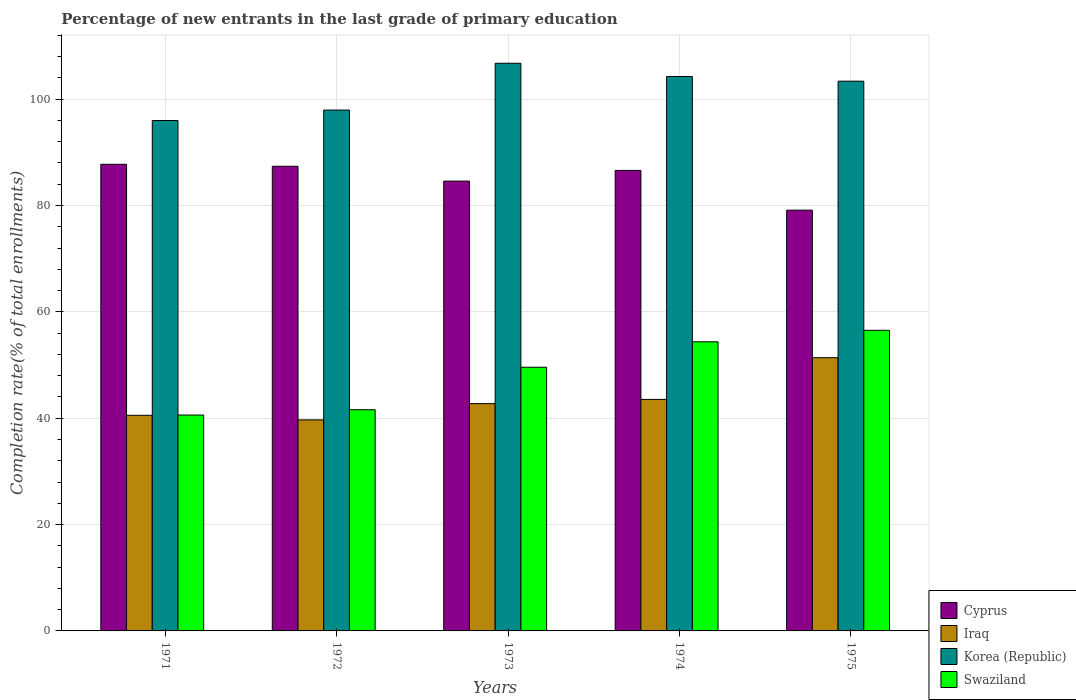How many groups of bars are there?
Offer a very short reply. 5. Are the number of bars per tick equal to the number of legend labels?
Provide a succinct answer. Yes. How many bars are there on the 1st tick from the left?
Provide a short and direct response. 4. What is the label of the 1st group of bars from the left?
Make the answer very short. 1971. In how many cases, is the number of bars for a given year not equal to the number of legend labels?
Make the answer very short. 0. What is the percentage of new entrants in Iraq in 1974?
Make the answer very short. 43.54. Across all years, what is the maximum percentage of new entrants in Iraq?
Your answer should be compact. 51.38. Across all years, what is the minimum percentage of new entrants in Cyprus?
Your response must be concise. 79.12. In which year was the percentage of new entrants in Iraq maximum?
Offer a terse response. 1975. In which year was the percentage of new entrants in Cyprus minimum?
Your answer should be very brief. 1975. What is the total percentage of new entrants in Swaziland in the graph?
Offer a terse response. 242.67. What is the difference between the percentage of new entrants in Cyprus in 1972 and that in 1975?
Your response must be concise. 8.26. What is the difference between the percentage of new entrants in Swaziland in 1973 and the percentage of new entrants in Korea (Republic) in 1974?
Provide a succinct answer. -54.67. What is the average percentage of new entrants in Iraq per year?
Keep it short and to the point. 43.58. In the year 1973, what is the difference between the percentage of new entrants in Korea (Republic) and percentage of new entrants in Cyprus?
Provide a short and direct response. 22.16. What is the ratio of the percentage of new entrants in Swaziland in 1973 to that in 1975?
Your response must be concise. 0.88. Is the percentage of new entrants in Iraq in 1972 less than that in 1975?
Your answer should be very brief. Yes. What is the difference between the highest and the second highest percentage of new entrants in Korea (Republic)?
Offer a very short reply. 2.5. What is the difference between the highest and the lowest percentage of new entrants in Swaziland?
Give a very brief answer. 15.93. In how many years, is the percentage of new entrants in Iraq greater than the average percentage of new entrants in Iraq taken over all years?
Your response must be concise. 1. Is it the case that in every year, the sum of the percentage of new entrants in Swaziland and percentage of new entrants in Iraq is greater than the sum of percentage of new entrants in Cyprus and percentage of new entrants in Korea (Republic)?
Offer a terse response. No. What does the 2nd bar from the right in 1975 represents?
Provide a succinct answer. Korea (Republic). Is it the case that in every year, the sum of the percentage of new entrants in Korea (Republic) and percentage of new entrants in Iraq is greater than the percentage of new entrants in Swaziland?
Make the answer very short. Yes. How many bars are there?
Ensure brevity in your answer.  20. How many years are there in the graph?
Make the answer very short. 5. What is the difference between two consecutive major ticks on the Y-axis?
Your answer should be very brief. 20. Are the values on the major ticks of Y-axis written in scientific E-notation?
Make the answer very short. No. Does the graph contain any zero values?
Offer a very short reply. No. Does the graph contain grids?
Make the answer very short. Yes. How many legend labels are there?
Your answer should be very brief. 4. What is the title of the graph?
Give a very brief answer. Percentage of new entrants in the last grade of primary education. Does "Cameroon" appear as one of the legend labels in the graph?
Make the answer very short. No. What is the label or title of the X-axis?
Offer a very short reply. Years. What is the label or title of the Y-axis?
Ensure brevity in your answer.  Completion rate(% of total enrollments). What is the Completion rate(% of total enrollments) in Cyprus in 1971?
Your answer should be very brief. 87.75. What is the Completion rate(% of total enrollments) in Iraq in 1971?
Provide a succinct answer. 40.55. What is the Completion rate(% of total enrollments) in Korea (Republic) in 1971?
Your response must be concise. 95.98. What is the Completion rate(% of total enrollments) of Swaziland in 1971?
Provide a succinct answer. 40.6. What is the Completion rate(% of total enrollments) in Cyprus in 1972?
Offer a terse response. 87.38. What is the Completion rate(% of total enrollments) of Iraq in 1972?
Your answer should be compact. 39.68. What is the Completion rate(% of total enrollments) of Korea (Republic) in 1972?
Make the answer very short. 97.95. What is the Completion rate(% of total enrollments) of Swaziland in 1972?
Your answer should be compact. 41.59. What is the Completion rate(% of total enrollments) in Cyprus in 1973?
Offer a very short reply. 84.59. What is the Completion rate(% of total enrollments) in Iraq in 1973?
Give a very brief answer. 42.75. What is the Completion rate(% of total enrollments) in Korea (Republic) in 1973?
Provide a succinct answer. 106.75. What is the Completion rate(% of total enrollments) in Swaziland in 1973?
Offer a terse response. 49.59. What is the Completion rate(% of total enrollments) of Cyprus in 1974?
Give a very brief answer. 86.6. What is the Completion rate(% of total enrollments) in Iraq in 1974?
Provide a short and direct response. 43.54. What is the Completion rate(% of total enrollments) in Korea (Republic) in 1974?
Your answer should be very brief. 104.25. What is the Completion rate(% of total enrollments) in Swaziland in 1974?
Your answer should be compact. 54.37. What is the Completion rate(% of total enrollments) of Cyprus in 1975?
Your answer should be very brief. 79.12. What is the Completion rate(% of total enrollments) of Iraq in 1975?
Your answer should be very brief. 51.38. What is the Completion rate(% of total enrollments) in Korea (Republic) in 1975?
Make the answer very short. 103.38. What is the Completion rate(% of total enrollments) of Swaziland in 1975?
Your response must be concise. 56.53. Across all years, what is the maximum Completion rate(% of total enrollments) in Cyprus?
Provide a short and direct response. 87.75. Across all years, what is the maximum Completion rate(% of total enrollments) in Iraq?
Provide a succinct answer. 51.38. Across all years, what is the maximum Completion rate(% of total enrollments) of Korea (Republic)?
Provide a succinct answer. 106.75. Across all years, what is the maximum Completion rate(% of total enrollments) in Swaziland?
Provide a succinct answer. 56.53. Across all years, what is the minimum Completion rate(% of total enrollments) of Cyprus?
Offer a very short reply. 79.12. Across all years, what is the minimum Completion rate(% of total enrollments) in Iraq?
Keep it short and to the point. 39.68. Across all years, what is the minimum Completion rate(% of total enrollments) of Korea (Republic)?
Keep it short and to the point. 95.98. Across all years, what is the minimum Completion rate(% of total enrollments) of Swaziland?
Make the answer very short. 40.6. What is the total Completion rate(% of total enrollments) in Cyprus in the graph?
Give a very brief answer. 425.43. What is the total Completion rate(% of total enrollments) in Iraq in the graph?
Make the answer very short. 217.89. What is the total Completion rate(% of total enrollments) in Korea (Republic) in the graph?
Provide a short and direct response. 508.3. What is the total Completion rate(% of total enrollments) of Swaziland in the graph?
Keep it short and to the point. 242.67. What is the difference between the Completion rate(% of total enrollments) in Cyprus in 1971 and that in 1972?
Ensure brevity in your answer.  0.37. What is the difference between the Completion rate(% of total enrollments) of Iraq in 1971 and that in 1972?
Make the answer very short. 0.86. What is the difference between the Completion rate(% of total enrollments) of Korea (Republic) in 1971 and that in 1972?
Your answer should be compact. -1.97. What is the difference between the Completion rate(% of total enrollments) of Swaziland in 1971 and that in 1972?
Ensure brevity in your answer.  -1. What is the difference between the Completion rate(% of total enrollments) in Cyprus in 1971 and that in 1973?
Provide a succinct answer. 3.16. What is the difference between the Completion rate(% of total enrollments) in Iraq in 1971 and that in 1973?
Make the answer very short. -2.2. What is the difference between the Completion rate(% of total enrollments) of Korea (Republic) in 1971 and that in 1973?
Offer a very short reply. -10.77. What is the difference between the Completion rate(% of total enrollments) in Swaziland in 1971 and that in 1973?
Offer a very short reply. -8.99. What is the difference between the Completion rate(% of total enrollments) in Cyprus in 1971 and that in 1974?
Make the answer very short. 1.15. What is the difference between the Completion rate(% of total enrollments) in Iraq in 1971 and that in 1974?
Ensure brevity in your answer.  -2.99. What is the difference between the Completion rate(% of total enrollments) of Korea (Republic) in 1971 and that in 1974?
Give a very brief answer. -8.28. What is the difference between the Completion rate(% of total enrollments) in Swaziland in 1971 and that in 1974?
Ensure brevity in your answer.  -13.77. What is the difference between the Completion rate(% of total enrollments) in Cyprus in 1971 and that in 1975?
Provide a succinct answer. 8.63. What is the difference between the Completion rate(% of total enrollments) of Iraq in 1971 and that in 1975?
Offer a very short reply. -10.84. What is the difference between the Completion rate(% of total enrollments) in Korea (Republic) in 1971 and that in 1975?
Your answer should be very brief. -7.4. What is the difference between the Completion rate(% of total enrollments) of Swaziland in 1971 and that in 1975?
Provide a short and direct response. -15.93. What is the difference between the Completion rate(% of total enrollments) of Cyprus in 1972 and that in 1973?
Make the answer very short. 2.79. What is the difference between the Completion rate(% of total enrollments) of Iraq in 1972 and that in 1973?
Keep it short and to the point. -3.06. What is the difference between the Completion rate(% of total enrollments) in Korea (Republic) in 1972 and that in 1973?
Provide a short and direct response. -8.8. What is the difference between the Completion rate(% of total enrollments) of Swaziland in 1972 and that in 1973?
Make the answer very short. -7.99. What is the difference between the Completion rate(% of total enrollments) in Cyprus in 1972 and that in 1974?
Your answer should be compact. 0.78. What is the difference between the Completion rate(% of total enrollments) in Iraq in 1972 and that in 1974?
Provide a succinct answer. -3.85. What is the difference between the Completion rate(% of total enrollments) in Korea (Republic) in 1972 and that in 1974?
Offer a very short reply. -6.31. What is the difference between the Completion rate(% of total enrollments) in Swaziland in 1972 and that in 1974?
Keep it short and to the point. -12.77. What is the difference between the Completion rate(% of total enrollments) of Cyprus in 1972 and that in 1975?
Ensure brevity in your answer.  8.26. What is the difference between the Completion rate(% of total enrollments) of Iraq in 1972 and that in 1975?
Your answer should be very brief. -11.7. What is the difference between the Completion rate(% of total enrollments) of Korea (Republic) in 1972 and that in 1975?
Make the answer very short. -5.43. What is the difference between the Completion rate(% of total enrollments) in Swaziland in 1972 and that in 1975?
Offer a very short reply. -14.94. What is the difference between the Completion rate(% of total enrollments) in Cyprus in 1973 and that in 1974?
Offer a very short reply. -2.01. What is the difference between the Completion rate(% of total enrollments) in Iraq in 1973 and that in 1974?
Give a very brief answer. -0.79. What is the difference between the Completion rate(% of total enrollments) of Korea (Republic) in 1973 and that in 1974?
Ensure brevity in your answer.  2.5. What is the difference between the Completion rate(% of total enrollments) of Swaziland in 1973 and that in 1974?
Give a very brief answer. -4.78. What is the difference between the Completion rate(% of total enrollments) of Cyprus in 1973 and that in 1975?
Your response must be concise. 5.47. What is the difference between the Completion rate(% of total enrollments) of Iraq in 1973 and that in 1975?
Your answer should be compact. -8.64. What is the difference between the Completion rate(% of total enrollments) in Korea (Republic) in 1973 and that in 1975?
Offer a terse response. 3.37. What is the difference between the Completion rate(% of total enrollments) in Swaziland in 1973 and that in 1975?
Ensure brevity in your answer.  -6.94. What is the difference between the Completion rate(% of total enrollments) of Cyprus in 1974 and that in 1975?
Provide a succinct answer. 7.48. What is the difference between the Completion rate(% of total enrollments) of Iraq in 1974 and that in 1975?
Offer a very short reply. -7.84. What is the difference between the Completion rate(% of total enrollments) of Korea (Republic) in 1974 and that in 1975?
Your response must be concise. 0.87. What is the difference between the Completion rate(% of total enrollments) of Swaziland in 1974 and that in 1975?
Offer a terse response. -2.16. What is the difference between the Completion rate(% of total enrollments) of Cyprus in 1971 and the Completion rate(% of total enrollments) of Iraq in 1972?
Make the answer very short. 48.06. What is the difference between the Completion rate(% of total enrollments) of Cyprus in 1971 and the Completion rate(% of total enrollments) of Korea (Republic) in 1972?
Your answer should be compact. -10.2. What is the difference between the Completion rate(% of total enrollments) of Cyprus in 1971 and the Completion rate(% of total enrollments) of Swaziland in 1972?
Make the answer very short. 46.16. What is the difference between the Completion rate(% of total enrollments) of Iraq in 1971 and the Completion rate(% of total enrollments) of Korea (Republic) in 1972?
Your answer should be very brief. -57.4. What is the difference between the Completion rate(% of total enrollments) in Iraq in 1971 and the Completion rate(% of total enrollments) in Swaziland in 1972?
Your answer should be compact. -1.05. What is the difference between the Completion rate(% of total enrollments) of Korea (Republic) in 1971 and the Completion rate(% of total enrollments) of Swaziland in 1972?
Your answer should be compact. 54.38. What is the difference between the Completion rate(% of total enrollments) of Cyprus in 1971 and the Completion rate(% of total enrollments) of Iraq in 1973?
Offer a terse response. 45. What is the difference between the Completion rate(% of total enrollments) of Cyprus in 1971 and the Completion rate(% of total enrollments) of Korea (Republic) in 1973?
Give a very brief answer. -19. What is the difference between the Completion rate(% of total enrollments) in Cyprus in 1971 and the Completion rate(% of total enrollments) in Swaziland in 1973?
Keep it short and to the point. 38.16. What is the difference between the Completion rate(% of total enrollments) in Iraq in 1971 and the Completion rate(% of total enrollments) in Korea (Republic) in 1973?
Offer a very short reply. -66.2. What is the difference between the Completion rate(% of total enrollments) in Iraq in 1971 and the Completion rate(% of total enrollments) in Swaziland in 1973?
Offer a terse response. -9.04. What is the difference between the Completion rate(% of total enrollments) in Korea (Republic) in 1971 and the Completion rate(% of total enrollments) in Swaziland in 1973?
Make the answer very short. 46.39. What is the difference between the Completion rate(% of total enrollments) of Cyprus in 1971 and the Completion rate(% of total enrollments) of Iraq in 1974?
Offer a very short reply. 44.21. What is the difference between the Completion rate(% of total enrollments) of Cyprus in 1971 and the Completion rate(% of total enrollments) of Korea (Republic) in 1974?
Your answer should be compact. -16.5. What is the difference between the Completion rate(% of total enrollments) in Cyprus in 1971 and the Completion rate(% of total enrollments) in Swaziland in 1974?
Provide a short and direct response. 33.38. What is the difference between the Completion rate(% of total enrollments) of Iraq in 1971 and the Completion rate(% of total enrollments) of Korea (Republic) in 1974?
Keep it short and to the point. -63.71. What is the difference between the Completion rate(% of total enrollments) of Iraq in 1971 and the Completion rate(% of total enrollments) of Swaziland in 1974?
Offer a very short reply. -13.82. What is the difference between the Completion rate(% of total enrollments) of Korea (Republic) in 1971 and the Completion rate(% of total enrollments) of Swaziland in 1974?
Provide a succinct answer. 41.61. What is the difference between the Completion rate(% of total enrollments) of Cyprus in 1971 and the Completion rate(% of total enrollments) of Iraq in 1975?
Keep it short and to the point. 36.37. What is the difference between the Completion rate(% of total enrollments) in Cyprus in 1971 and the Completion rate(% of total enrollments) in Korea (Republic) in 1975?
Your answer should be compact. -15.63. What is the difference between the Completion rate(% of total enrollments) of Cyprus in 1971 and the Completion rate(% of total enrollments) of Swaziland in 1975?
Offer a terse response. 31.22. What is the difference between the Completion rate(% of total enrollments) of Iraq in 1971 and the Completion rate(% of total enrollments) of Korea (Republic) in 1975?
Your answer should be very brief. -62.83. What is the difference between the Completion rate(% of total enrollments) in Iraq in 1971 and the Completion rate(% of total enrollments) in Swaziland in 1975?
Give a very brief answer. -15.98. What is the difference between the Completion rate(% of total enrollments) of Korea (Republic) in 1971 and the Completion rate(% of total enrollments) of Swaziland in 1975?
Provide a short and direct response. 39.45. What is the difference between the Completion rate(% of total enrollments) of Cyprus in 1972 and the Completion rate(% of total enrollments) of Iraq in 1973?
Provide a succinct answer. 44.63. What is the difference between the Completion rate(% of total enrollments) in Cyprus in 1972 and the Completion rate(% of total enrollments) in Korea (Republic) in 1973?
Your answer should be very brief. -19.37. What is the difference between the Completion rate(% of total enrollments) of Cyprus in 1972 and the Completion rate(% of total enrollments) of Swaziland in 1973?
Your response must be concise. 37.79. What is the difference between the Completion rate(% of total enrollments) in Iraq in 1972 and the Completion rate(% of total enrollments) in Korea (Republic) in 1973?
Provide a short and direct response. -67.06. What is the difference between the Completion rate(% of total enrollments) in Iraq in 1972 and the Completion rate(% of total enrollments) in Swaziland in 1973?
Your answer should be very brief. -9.9. What is the difference between the Completion rate(% of total enrollments) in Korea (Republic) in 1972 and the Completion rate(% of total enrollments) in Swaziland in 1973?
Ensure brevity in your answer.  48.36. What is the difference between the Completion rate(% of total enrollments) in Cyprus in 1972 and the Completion rate(% of total enrollments) in Iraq in 1974?
Your response must be concise. 43.84. What is the difference between the Completion rate(% of total enrollments) in Cyprus in 1972 and the Completion rate(% of total enrollments) in Korea (Republic) in 1974?
Give a very brief answer. -16.87. What is the difference between the Completion rate(% of total enrollments) in Cyprus in 1972 and the Completion rate(% of total enrollments) in Swaziland in 1974?
Keep it short and to the point. 33.01. What is the difference between the Completion rate(% of total enrollments) in Iraq in 1972 and the Completion rate(% of total enrollments) in Korea (Republic) in 1974?
Your answer should be compact. -64.57. What is the difference between the Completion rate(% of total enrollments) in Iraq in 1972 and the Completion rate(% of total enrollments) in Swaziland in 1974?
Keep it short and to the point. -14.68. What is the difference between the Completion rate(% of total enrollments) of Korea (Republic) in 1972 and the Completion rate(% of total enrollments) of Swaziland in 1974?
Make the answer very short. 43.58. What is the difference between the Completion rate(% of total enrollments) of Cyprus in 1972 and the Completion rate(% of total enrollments) of Iraq in 1975?
Your response must be concise. 36. What is the difference between the Completion rate(% of total enrollments) of Cyprus in 1972 and the Completion rate(% of total enrollments) of Korea (Republic) in 1975?
Provide a short and direct response. -16. What is the difference between the Completion rate(% of total enrollments) in Cyprus in 1972 and the Completion rate(% of total enrollments) in Swaziland in 1975?
Your response must be concise. 30.85. What is the difference between the Completion rate(% of total enrollments) in Iraq in 1972 and the Completion rate(% of total enrollments) in Korea (Republic) in 1975?
Your answer should be very brief. -63.7. What is the difference between the Completion rate(% of total enrollments) in Iraq in 1972 and the Completion rate(% of total enrollments) in Swaziland in 1975?
Your response must be concise. -16.84. What is the difference between the Completion rate(% of total enrollments) in Korea (Republic) in 1972 and the Completion rate(% of total enrollments) in Swaziland in 1975?
Your response must be concise. 41.42. What is the difference between the Completion rate(% of total enrollments) of Cyprus in 1973 and the Completion rate(% of total enrollments) of Iraq in 1974?
Provide a short and direct response. 41.05. What is the difference between the Completion rate(% of total enrollments) of Cyprus in 1973 and the Completion rate(% of total enrollments) of Korea (Republic) in 1974?
Provide a short and direct response. -19.66. What is the difference between the Completion rate(% of total enrollments) of Cyprus in 1973 and the Completion rate(% of total enrollments) of Swaziland in 1974?
Give a very brief answer. 30.22. What is the difference between the Completion rate(% of total enrollments) in Iraq in 1973 and the Completion rate(% of total enrollments) in Korea (Republic) in 1974?
Keep it short and to the point. -61.51. What is the difference between the Completion rate(% of total enrollments) of Iraq in 1973 and the Completion rate(% of total enrollments) of Swaziland in 1974?
Make the answer very short. -11.62. What is the difference between the Completion rate(% of total enrollments) of Korea (Republic) in 1973 and the Completion rate(% of total enrollments) of Swaziland in 1974?
Your answer should be compact. 52.38. What is the difference between the Completion rate(% of total enrollments) of Cyprus in 1973 and the Completion rate(% of total enrollments) of Iraq in 1975?
Keep it short and to the point. 33.21. What is the difference between the Completion rate(% of total enrollments) of Cyprus in 1973 and the Completion rate(% of total enrollments) of Korea (Republic) in 1975?
Give a very brief answer. -18.79. What is the difference between the Completion rate(% of total enrollments) in Cyprus in 1973 and the Completion rate(% of total enrollments) in Swaziland in 1975?
Your response must be concise. 28.06. What is the difference between the Completion rate(% of total enrollments) in Iraq in 1973 and the Completion rate(% of total enrollments) in Korea (Republic) in 1975?
Your answer should be compact. -60.63. What is the difference between the Completion rate(% of total enrollments) in Iraq in 1973 and the Completion rate(% of total enrollments) in Swaziland in 1975?
Ensure brevity in your answer.  -13.78. What is the difference between the Completion rate(% of total enrollments) in Korea (Republic) in 1973 and the Completion rate(% of total enrollments) in Swaziland in 1975?
Your answer should be compact. 50.22. What is the difference between the Completion rate(% of total enrollments) in Cyprus in 1974 and the Completion rate(% of total enrollments) in Iraq in 1975?
Offer a terse response. 35.22. What is the difference between the Completion rate(% of total enrollments) of Cyprus in 1974 and the Completion rate(% of total enrollments) of Korea (Republic) in 1975?
Your response must be concise. -16.78. What is the difference between the Completion rate(% of total enrollments) in Cyprus in 1974 and the Completion rate(% of total enrollments) in Swaziland in 1975?
Your answer should be very brief. 30.07. What is the difference between the Completion rate(% of total enrollments) in Iraq in 1974 and the Completion rate(% of total enrollments) in Korea (Republic) in 1975?
Provide a short and direct response. -59.84. What is the difference between the Completion rate(% of total enrollments) in Iraq in 1974 and the Completion rate(% of total enrollments) in Swaziland in 1975?
Your response must be concise. -12.99. What is the difference between the Completion rate(% of total enrollments) in Korea (Republic) in 1974 and the Completion rate(% of total enrollments) in Swaziland in 1975?
Keep it short and to the point. 47.72. What is the average Completion rate(% of total enrollments) in Cyprus per year?
Make the answer very short. 85.09. What is the average Completion rate(% of total enrollments) in Iraq per year?
Provide a short and direct response. 43.58. What is the average Completion rate(% of total enrollments) of Korea (Republic) per year?
Ensure brevity in your answer.  101.66. What is the average Completion rate(% of total enrollments) of Swaziland per year?
Your response must be concise. 48.53. In the year 1971, what is the difference between the Completion rate(% of total enrollments) of Cyprus and Completion rate(% of total enrollments) of Iraq?
Provide a short and direct response. 47.2. In the year 1971, what is the difference between the Completion rate(% of total enrollments) of Cyprus and Completion rate(% of total enrollments) of Korea (Republic)?
Make the answer very short. -8.23. In the year 1971, what is the difference between the Completion rate(% of total enrollments) in Cyprus and Completion rate(% of total enrollments) in Swaziland?
Make the answer very short. 47.15. In the year 1971, what is the difference between the Completion rate(% of total enrollments) in Iraq and Completion rate(% of total enrollments) in Korea (Republic)?
Keep it short and to the point. -55.43. In the year 1971, what is the difference between the Completion rate(% of total enrollments) of Iraq and Completion rate(% of total enrollments) of Swaziland?
Keep it short and to the point. -0.05. In the year 1971, what is the difference between the Completion rate(% of total enrollments) of Korea (Republic) and Completion rate(% of total enrollments) of Swaziland?
Make the answer very short. 55.38. In the year 1972, what is the difference between the Completion rate(% of total enrollments) in Cyprus and Completion rate(% of total enrollments) in Iraq?
Ensure brevity in your answer.  47.69. In the year 1972, what is the difference between the Completion rate(% of total enrollments) in Cyprus and Completion rate(% of total enrollments) in Korea (Republic)?
Offer a terse response. -10.57. In the year 1972, what is the difference between the Completion rate(% of total enrollments) of Cyprus and Completion rate(% of total enrollments) of Swaziland?
Keep it short and to the point. 45.78. In the year 1972, what is the difference between the Completion rate(% of total enrollments) of Iraq and Completion rate(% of total enrollments) of Korea (Republic)?
Your response must be concise. -58.26. In the year 1972, what is the difference between the Completion rate(% of total enrollments) of Iraq and Completion rate(% of total enrollments) of Swaziland?
Your answer should be compact. -1.91. In the year 1972, what is the difference between the Completion rate(% of total enrollments) of Korea (Republic) and Completion rate(% of total enrollments) of Swaziland?
Keep it short and to the point. 56.35. In the year 1973, what is the difference between the Completion rate(% of total enrollments) of Cyprus and Completion rate(% of total enrollments) of Iraq?
Your answer should be very brief. 41.84. In the year 1973, what is the difference between the Completion rate(% of total enrollments) of Cyprus and Completion rate(% of total enrollments) of Korea (Republic)?
Provide a succinct answer. -22.16. In the year 1973, what is the difference between the Completion rate(% of total enrollments) in Cyprus and Completion rate(% of total enrollments) in Swaziland?
Ensure brevity in your answer.  35. In the year 1973, what is the difference between the Completion rate(% of total enrollments) of Iraq and Completion rate(% of total enrollments) of Korea (Republic)?
Your answer should be compact. -64. In the year 1973, what is the difference between the Completion rate(% of total enrollments) in Iraq and Completion rate(% of total enrollments) in Swaziland?
Give a very brief answer. -6.84. In the year 1973, what is the difference between the Completion rate(% of total enrollments) of Korea (Republic) and Completion rate(% of total enrollments) of Swaziland?
Make the answer very short. 57.16. In the year 1974, what is the difference between the Completion rate(% of total enrollments) in Cyprus and Completion rate(% of total enrollments) in Iraq?
Your answer should be very brief. 43.06. In the year 1974, what is the difference between the Completion rate(% of total enrollments) of Cyprus and Completion rate(% of total enrollments) of Korea (Republic)?
Provide a succinct answer. -17.65. In the year 1974, what is the difference between the Completion rate(% of total enrollments) of Cyprus and Completion rate(% of total enrollments) of Swaziland?
Provide a succinct answer. 32.23. In the year 1974, what is the difference between the Completion rate(% of total enrollments) of Iraq and Completion rate(% of total enrollments) of Korea (Republic)?
Provide a short and direct response. -60.72. In the year 1974, what is the difference between the Completion rate(% of total enrollments) in Iraq and Completion rate(% of total enrollments) in Swaziland?
Offer a very short reply. -10.83. In the year 1974, what is the difference between the Completion rate(% of total enrollments) of Korea (Republic) and Completion rate(% of total enrollments) of Swaziland?
Your answer should be compact. 49.88. In the year 1975, what is the difference between the Completion rate(% of total enrollments) of Cyprus and Completion rate(% of total enrollments) of Iraq?
Offer a terse response. 27.74. In the year 1975, what is the difference between the Completion rate(% of total enrollments) in Cyprus and Completion rate(% of total enrollments) in Korea (Republic)?
Give a very brief answer. -24.26. In the year 1975, what is the difference between the Completion rate(% of total enrollments) in Cyprus and Completion rate(% of total enrollments) in Swaziland?
Your response must be concise. 22.59. In the year 1975, what is the difference between the Completion rate(% of total enrollments) of Iraq and Completion rate(% of total enrollments) of Korea (Republic)?
Your answer should be very brief. -52. In the year 1975, what is the difference between the Completion rate(% of total enrollments) of Iraq and Completion rate(% of total enrollments) of Swaziland?
Provide a succinct answer. -5.15. In the year 1975, what is the difference between the Completion rate(% of total enrollments) of Korea (Republic) and Completion rate(% of total enrollments) of Swaziland?
Ensure brevity in your answer.  46.85. What is the ratio of the Completion rate(% of total enrollments) in Iraq in 1971 to that in 1972?
Offer a terse response. 1.02. What is the ratio of the Completion rate(% of total enrollments) of Korea (Republic) in 1971 to that in 1972?
Your answer should be compact. 0.98. What is the ratio of the Completion rate(% of total enrollments) in Swaziland in 1971 to that in 1972?
Provide a succinct answer. 0.98. What is the ratio of the Completion rate(% of total enrollments) of Cyprus in 1971 to that in 1973?
Your answer should be compact. 1.04. What is the ratio of the Completion rate(% of total enrollments) of Iraq in 1971 to that in 1973?
Make the answer very short. 0.95. What is the ratio of the Completion rate(% of total enrollments) of Korea (Republic) in 1971 to that in 1973?
Make the answer very short. 0.9. What is the ratio of the Completion rate(% of total enrollments) in Swaziland in 1971 to that in 1973?
Your answer should be compact. 0.82. What is the ratio of the Completion rate(% of total enrollments) in Cyprus in 1971 to that in 1974?
Offer a very short reply. 1.01. What is the ratio of the Completion rate(% of total enrollments) in Iraq in 1971 to that in 1974?
Provide a succinct answer. 0.93. What is the ratio of the Completion rate(% of total enrollments) in Korea (Republic) in 1971 to that in 1974?
Give a very brief answer. 0.92. What is the ratio of the Completion rate(% of total enrollments) of Swaziland in 1971 to that in 1974?
Ensure brevity in your answer.  0.75. What is the ratio of the Completion rate(% of total enrollments) of Cyprus in 1971 to that in 1975?
Make the answer very short. 1.11. What is the ratio of the Completion rate(% of total enrollments) of Iraq in 1971 to that in 1975?
Provide a short and direct response. 0.79. What is the ratio of the Completion rate(% of total enrollments) of Korea (Republic) in 1971 to that in 1975?
Offer a very short reply. 0.93. What is the ratio of the Completion rate(% of total enrollments) of Swaziland in 1971 to that in 1975?
Provide a succinct answer. 0.72. What is the ratio of the Completion rate(% of total enrollments) of Cyprus in 1972 to that in 1973?
Offer a terse response. 1.03. What is the ratio of the Completion rate(% of total enrollments) in Iraq in 1972 to that in 1973?
Give a very brief answer. 0.93. What is the ratio of the Completion rate(% of total enrollments) in Korea (Republic) in 1972 to that in 1973?
Offer a very short reply. 0.92. What is the ratio of the Completion rate(% of total enrollments) in Swaziland in 1972 to that in 1973?
Give a very brief answer. 0.84. What is the ratio of the Completion rate(% of total enrollments) in Cyprus in 1972 to that in 1974?
Give a very brief answer. 1.01. What is the ratio of the Completion rate(% of total enrollments) of Iraq in 1972 to that in 1974?
Provide a succinct answer. 0.91. What is the ratio of the Completion rate(% of total enrollments) in Korea (Republic) in 1972 to that in 1974?
Keep it short and to the point. 0.94. What is the ratio of the Completion rate(% of total enrollments) of Swaziland in 1972 to that in 1974?
Provide a succinct answer. 0.77. What is the ratio of the Completion rate(% of total enrollments) in Cyprus in 1972 to that in 1975?
Your response must be concise. 1.1. What is the ratio of the Completion rate(% of total enrollments) in Iraq in 1972 to that in 1975?
Your response must be concise. 0.77. What is the ratio of the Completion rate(% of total enrollments) of Korea (Republic) in 1972 to that in 1975?
Your answer should be very brief. 0.95. What is the ratio of the Completion rate(% of total enrollments) in Swaziland in 1972 to that in 1975?
Keep it short and to the point. 0.74. What is the ratio of the Completion rate(% of total enrollments) in Cyprus in 1973 to that in 1974?
Provide a short and direct response. 0.98. What is the ratio of the Completion rate(% of total enrollments) in Iraq in 1973 to that in 1974?
Offer a very short reply. 0.98. What is the ratio of the Completion rate(% of total enrollments) of Swaziland in 1973 to that in 1974?
Provide a succinct answer. 0.91. What is the ratio of the Completion rate(% of total enrollments) in Cyprus in 1973 to that in 1975?
Ensure brevity in your answer.  1.07. What is the ratio of the Completion rate(% of total enrollments) in Iraq in 1973 to that in 1975?
Give a very brief answer. 0.83. What is the ratio of the Completion rate(% of total enrollments) of Korea (Republic) in 1973 to that in 1975?
Your answer should be very brief. 1.03. What is the ratio of the Completion rate(% of total enrollments) in Swaziland in 1973 to that in 1975?
Offer a very short reply. 0.88. What is the ratio of the Completion rate(% of total enrollments) in Cyprus in 1974 to that in 1975?
Make the answer very short. 1.09. What is the ratio of the Completion rate(% of total enrollments) of Iraq in 1974 to that in 1975?
Make the answer very short. 0.85. What is the ratio of the Completion rate(% of total enrollments) of Korea (Republic) in 1974 to that in 1975?
Ensure brevity in your answer.  1.01. What is the ratio of the Completion rate(% of total enrollments) in Swaziland in 1974 to that in 1975?
Keep it short and to the point. 0.96. What is the difference between the highest and the second highest Completion rate(% of total enrollments) of Cyprus?
Provide a short and direct response. 0.37. What is the difference between the highest and the second highest Completion rate(% of total enrollments) of Iraq?
Provide a short and direct response. 7.84. What is the difference between the highest and the second highest Completion rate(% of total enrollments) in Korea (Republic)?
Provide a succinct answer. 2.5. What is the difference between the highest and the second highest Completion rate(% of total enrollments) of Swaziland?
Your answer should be compact. 2.16. What is the difference between the highest and the lowest Completion rate(% of total enrollments) of Cyprus?
Your answer should be very brief. 8.63. What is the difference between the highest and the lowest Completion rate(% of total enrollments) of Iraq?
Provide a succinct answer. 11.7. What is the difference between the highest and the lowest Completion rate(% of total enrollments) in Korea (Republic)?
Offer a very short reply. 10.77. What is the difference between the highest and the lowest Completion rate(% of total enrollments) of Swaziland?
Offer a very short reply. 15.93. 